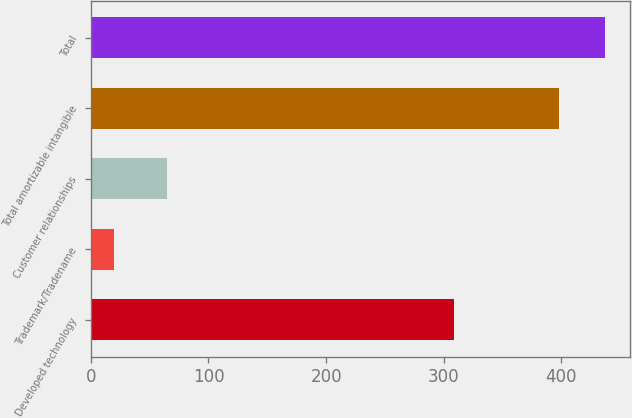Convert chart to OTSL. <chart><loc_0><loc_0><loc_500><loc_500><bar_chart><fcel>Developed technology<fcel>Trademark/Tradename<fcel>Customer relationships<fcel>Total amortizable intangible<fcel>Total<nl><fcel>309<fcel>20<fcel>65<fcel>398<fcel>437<nl></chart> 